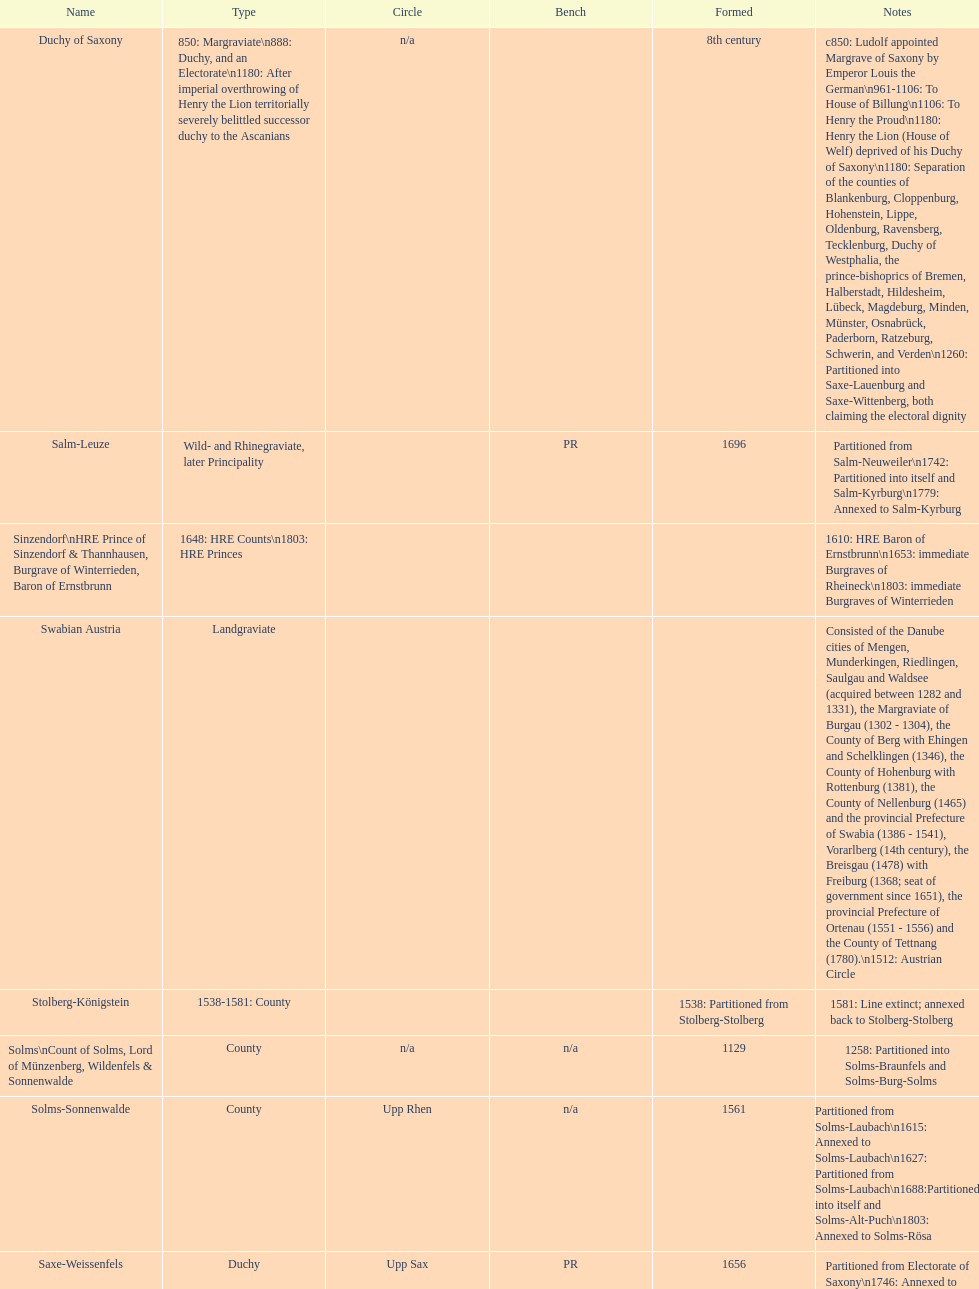How many states were of the same type as stuhlingen? 3. 